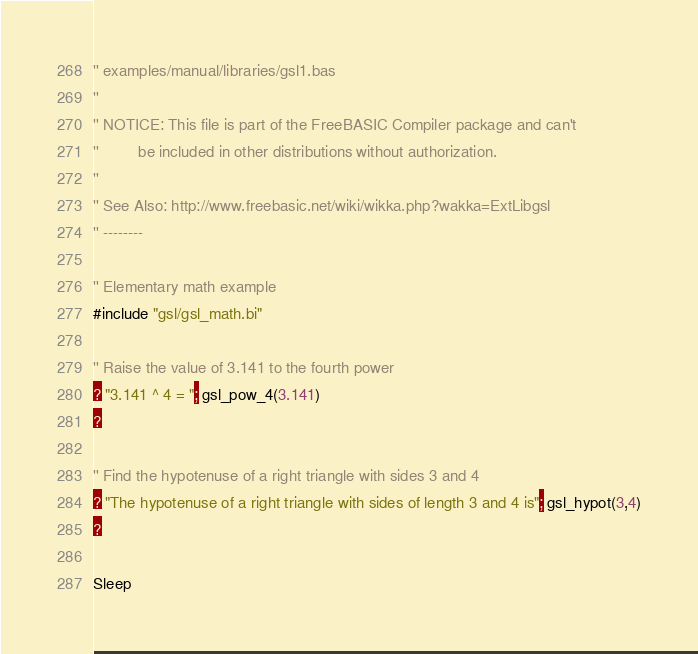<code> <loc_0><loc_0><loc_500><loc_500><_VisualBasic_>'' examples/manual/libraries/gsl1.bas
''
'' NOTICE: This file is part of the FreeBASIC Compiler package and can't
''         be included in other distributions without authorization.
''
'' See Also: http://www.freebasic.net/wiki/wikka.php?wakka=ExtLibgsl
'' --------

'' Elementary math example
#include "gsl/gsl_math.bi"

'' Raise the value of 3.141 to the fourth power
? "3.141 ^ 4 = "; gsl_pow_4(3.141)
?

'' Find the hypotenuse of a right triangle with sides 3 and 4 
? "The hypotenuse of a right triangle with sides of length 3 and 4 is"; gsl_hypot(3,4)
?

Sleep
</code> 